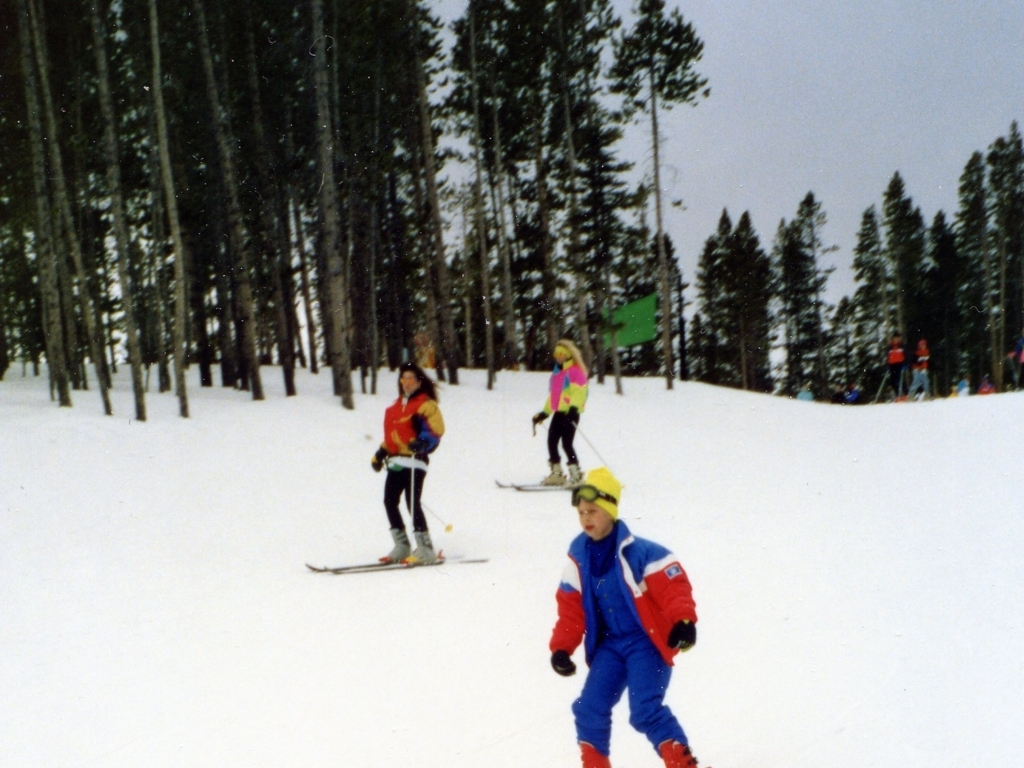What season is depicted in this image, and what activity are the people engaged in? The image depicts winter, identifiable by the snow-covered landscape. The people are engaged in skiing, a popular winter sport, as evidenced by their skis and colorful winter attire. 